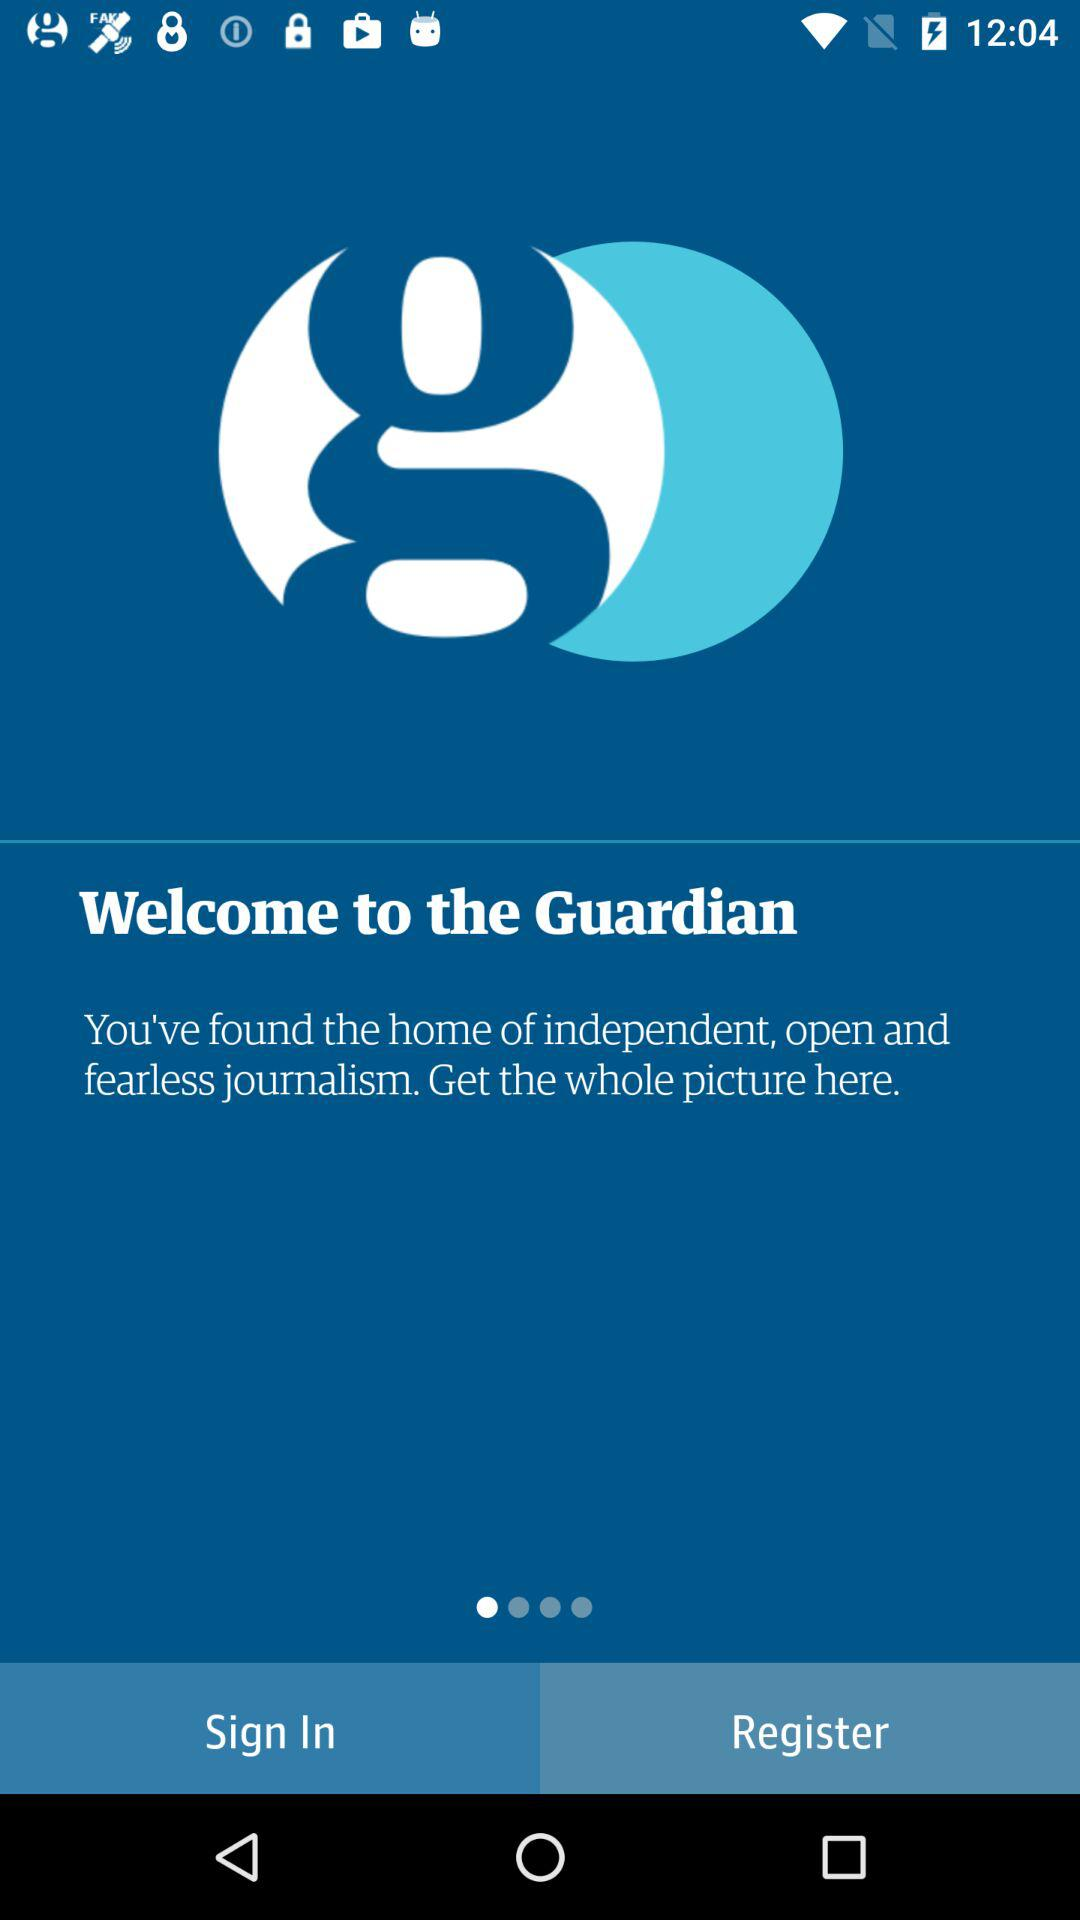What is the name of the application? The name of the application is "Guardian". 